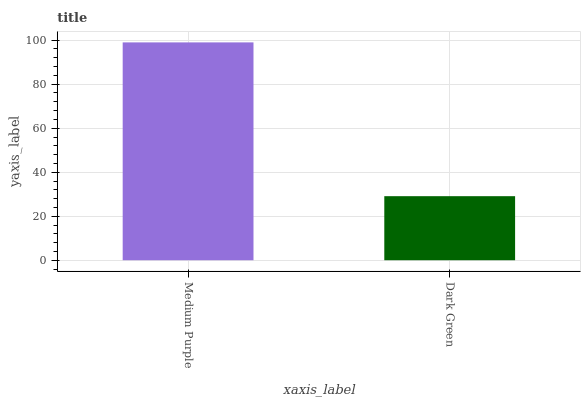Is Dark Green the minimum?
Answer yes or no. Yes. Is Medium Purple the maximum?
Answer yes or no. Yes. Is Dark Green the maximum?
Answer yes or no. No. Is Medium Purple greater than Dark Green?
Answer yes or no. Yes. Is Dark Green less than Medium Purple?
Answer yes or no. Yes. Is Dark Green greater than Medium Purple?
Answer yes or no. No. Is Medium Purple less than Dark Green?
Answer yes or no. No. Is Medium Purple the high median?
Answer yes or no. Yes. Is Dark Green the low median?
Answer yes or no. Yes. Is Dark Green the high median?
Answer yes or no. No. Is Medium Purple the low median?
Answer yes or no. No. 